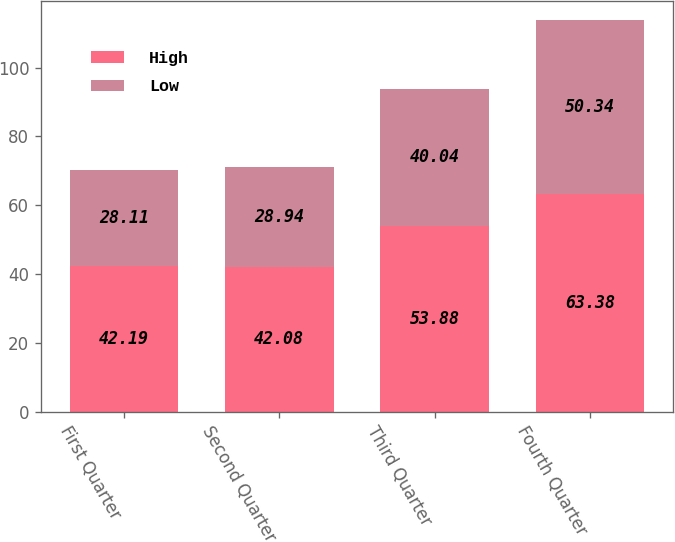<chart> <loc_0><loc_0><loc_500><loc_500><stacked_bar_chart><ecel><fcel>First Quarter<fcel>Second Quarter<fcel>Third Quarter<fcel>Fourth Quarter<nl><fcel>High<fcel>42.19<fcel>42.08<fcel>53.88<fcel>63.38<nl><fcel>Low<fcel>28.11<fcel>28.94<fcel>40.04<fcel>50.34<nl></chart> 